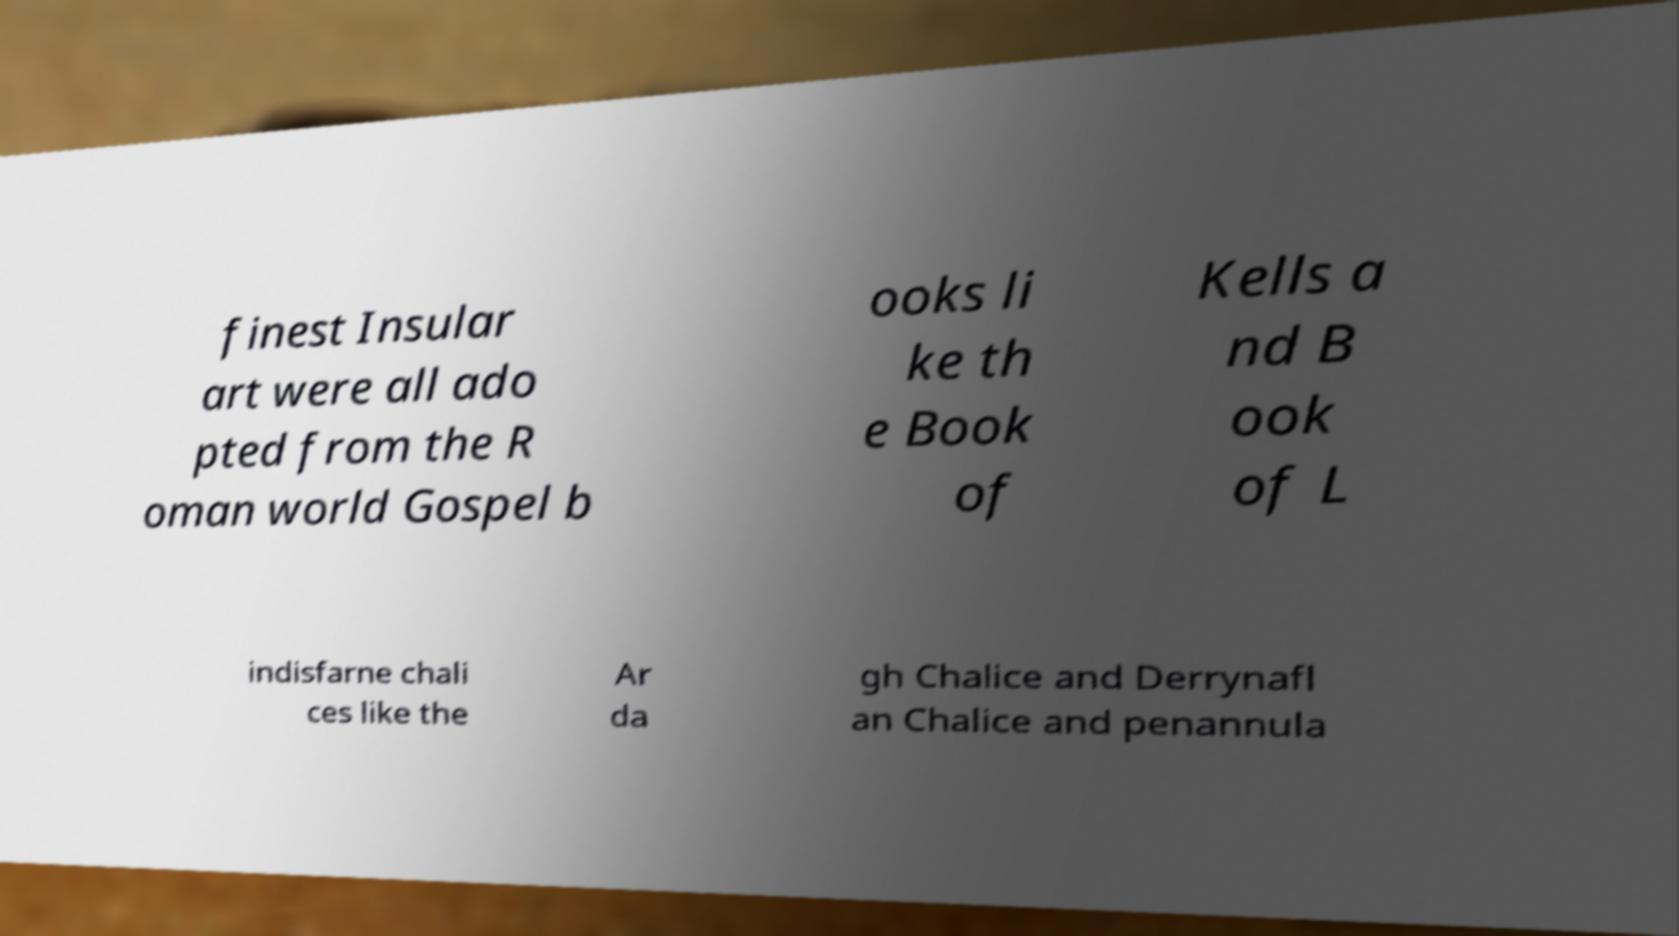Can you accurately transcribe the text from the provided image for me? finest Insular art were all ado pted from the R oman world Gospel b ooks li ke th e Book of Kells a nd B ook of L indisfarne chali ces like the Ar da gh Chalice and Derrynafl an Chalice and penannula 